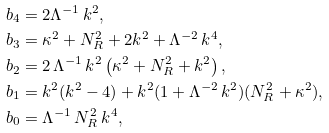<formula> <loc_0><loc_0><loc_500><loc_500>b _ { 4 } & = 2 \Lambda ^ { - 1 } \, k ^ { 2 } , \\ b _ { 3 } & = \kappa ^ { 2 } + N ^ { 2 } _ { R } + 2 k ^ { 2 } + \Lambda ^ { - 2 } \, k ^ { 4 } , \\ b _ { 2 } & = 2 \, \Lambda ^ { - 1 } \, k ^ { 2 } \left ( \kappa ^ { 2 } + N ^ { 2 } _ { R } + k ^ { 2 } \right ) , \\ b _ { 1 } & = k ^ { 2 } ( k ^ { 2 } - 4 ) + k ^ { 2 } ( 1 + \Lambda ^ { - 2 } \, k ^ { 2 } ) ( N ^ { 2 } _ { R } + \kappa ^ { 2 } ) , \\ b _ { 0 } & = \Lambda ^ { - 1 } \, N ^ { 2 } _ { R } \, k ^ { 4 } ,</formula> 